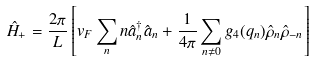Convert formula to latex. <formula><loc_0><loc_0><loc_500><loc_500>\hat { H } _ { + } = \frac { 2 \pi } { L } \left [ v _ { F } \sum _ { n } n \hat { a } _ { n } ^ { \dagger } \hat { a } _ { n } + \frac { 1 } { 4 \pi } \sum _ { n \neq 0 } g _ { 4 } ( q _ { n } ) \hat { \rho } _ { n } \hat { \rho } _ { - n } \right ]</formula> 